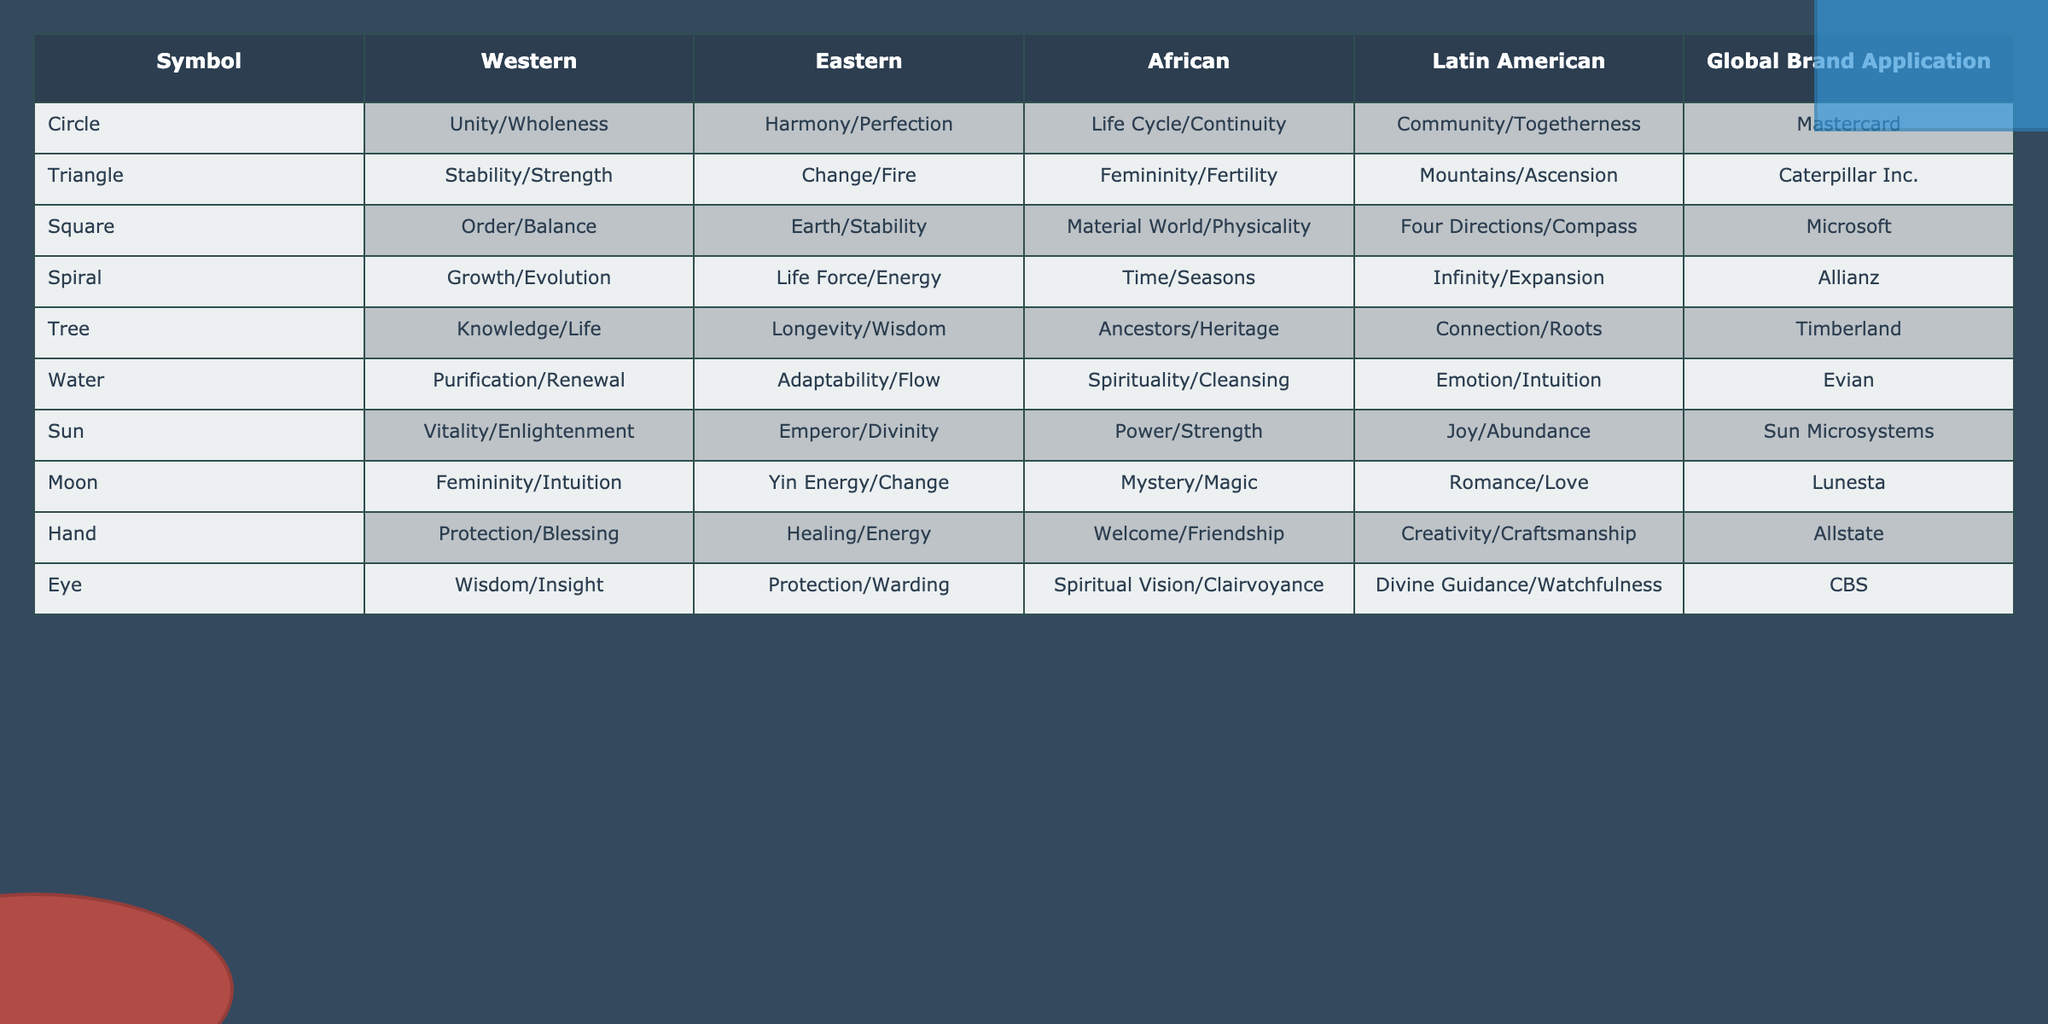What does the symbol "Tree" represent in Eastern culture? The symbol "Tree" in Eastern culture is associated with "Longevity/Wisdom," according to the table.
Answer: Longevity/Wisdom Which global brand is associated with the symbol "Spiral"? The symbol "Spiral" is associated with the global brand "Allianz," as indicated in the table.
Answer: Allianz Is the symbol "Circle" used to represent "Community/Togetherness" in African culture? In the table, the symbol "Circle" represents "Life Cycle/Continuity" in African culture, so this statement is false.
Answer: No What are the differences in symbolism for Water between Western and Latin American cultures? In the Western culture, Water symbolizes "Purification/Renewal," while in Latin American culture, it symbolizes "Emotion/Intuition," highlighting a difference in focus on physical vs. emotional aspects.
Answer: Purification/Renewal vs. Emotion/Intuition Which symbols are associated with "Strength" and how do they differ across cultures? The symbol "Sun" represents "Power/Strength" in African culture, while the "Eye" represents "Spiritual Vision/Clairvoyance" in African culture as well. The "Triangle" also symbolizes "Stability/Strength" in Western culture. Each symbol reflects different interpretations of strength—physical, spiritual, and emotional.
Answer: Sun, Eye, and Triangle How many symbols represent "Life" and what are they? The table shows that "Circle" represents "Life Cycle/Continuity," "Spiral" represents "Growth/Evolution," and "Tree" represents "Knowledge/Life," totaling three symbols representing concepts of life.
Answer: Three: Circle, Spiral, Tree Which global brand has themes of community and togetherness in its symbolism? The global brand "Mastercard" is associated with the symbol "Circle," which represents "Community/Togetherness," indicating a focus on inclusivity in its branding.
Answer: Mastercard What is the commonality in the representation of "Circle" across different cultures? The "Circle" symbol consistently embodies themes of unity or wholeness in Western culture, harmony or perfection in Eastern culture, life cycle or continuity in African culture, and community or togetherness in Latin American culture, showing a universal appreciation for these themes.
Answer: Unity/Wholeness, Harmony/Perfection, Life Cycle/Continuity, Community/Togetherness Which symbol represents both "Femininity" and "Intuition," and in what cultures does this occur? The symbol "Moon" represents "Femininity/Intuition" in Western culture, and "Yin Energy/Change" in Eastern culture, signifying a link between femininity and intuition across cultures.
Answer: Moon How does the representation of "Stability" differ between Western and African cultures? In Western culture, the "Triangle" symbolizes "Stability/Strength." In contrast, African culture does not have a direct representation of stability in the data, suggesting that the concept is interpreted differently or is less emphasized.
Answer: Triangle (Western), none (African) 